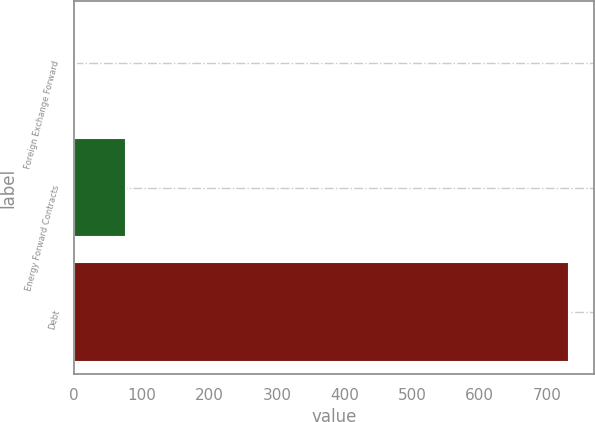Convert chart. <chart><loc_0><loc_0><loc_500><loc_500><bar_chart><fcel>Foreign Exchange Forward<fcel>Energy Forward Contracts<fcel>Debt<nl><fcel>3.1<fcel>76.01<fcel>732.2<nl></chart> 